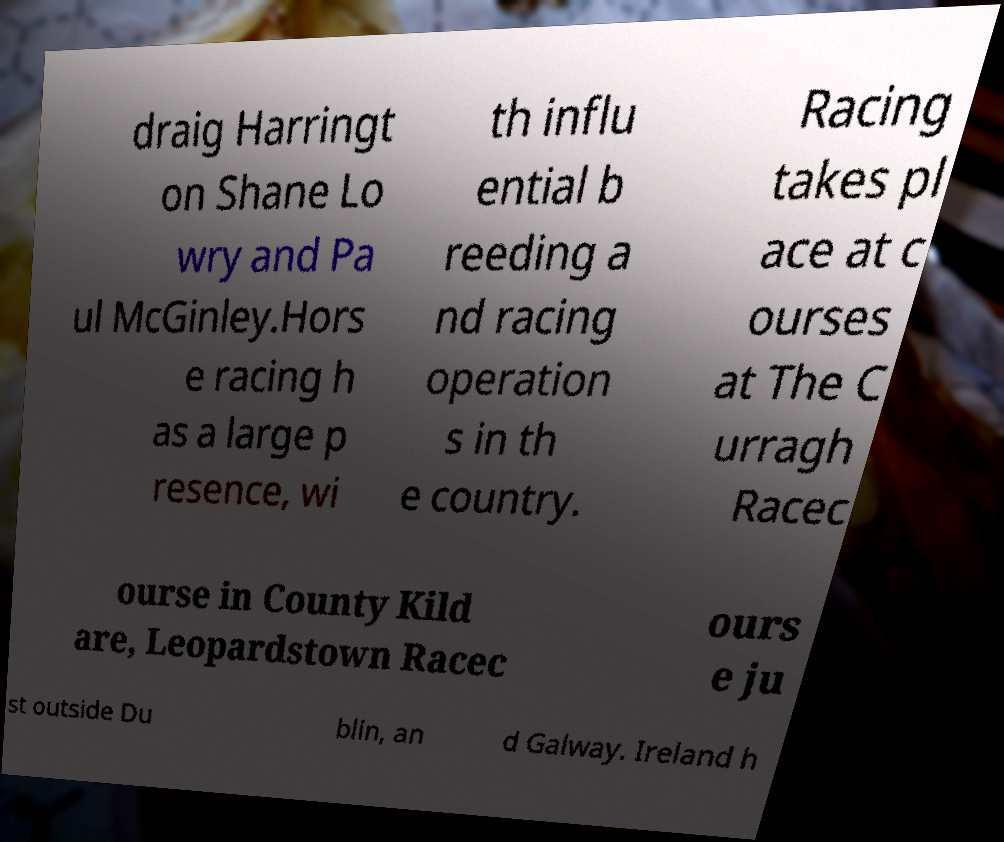Could you extract and type out the text from this image? draig Harringt on Shane Lo wry and Pa ul McGinley.Hors e racing h as a large p resence, wi th influ ential b reeding a nd racing operation s in th e country. Racing takes pl ace at c ourses at The C urragh Racec ourse in County Kild are, Leopardstown Racec ours e ju st outside Du blin, an d Galway. Ireland h 